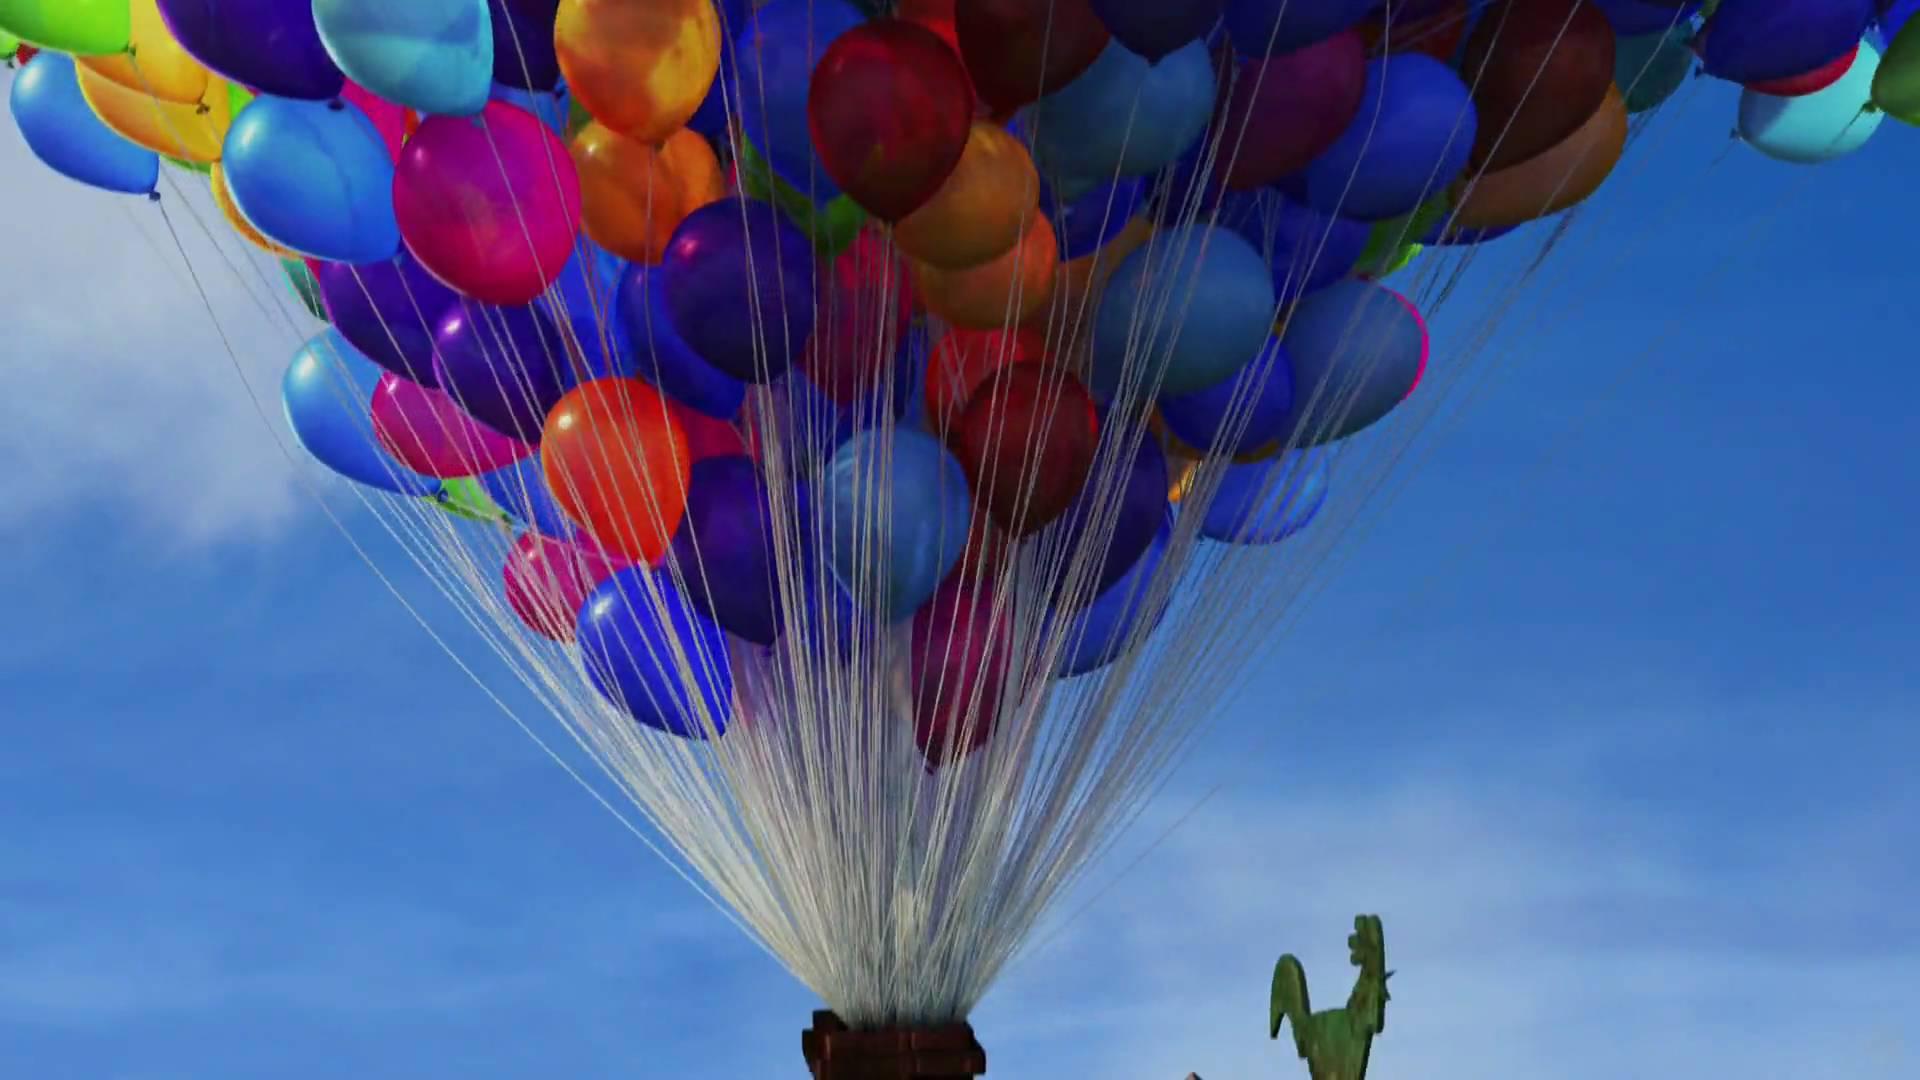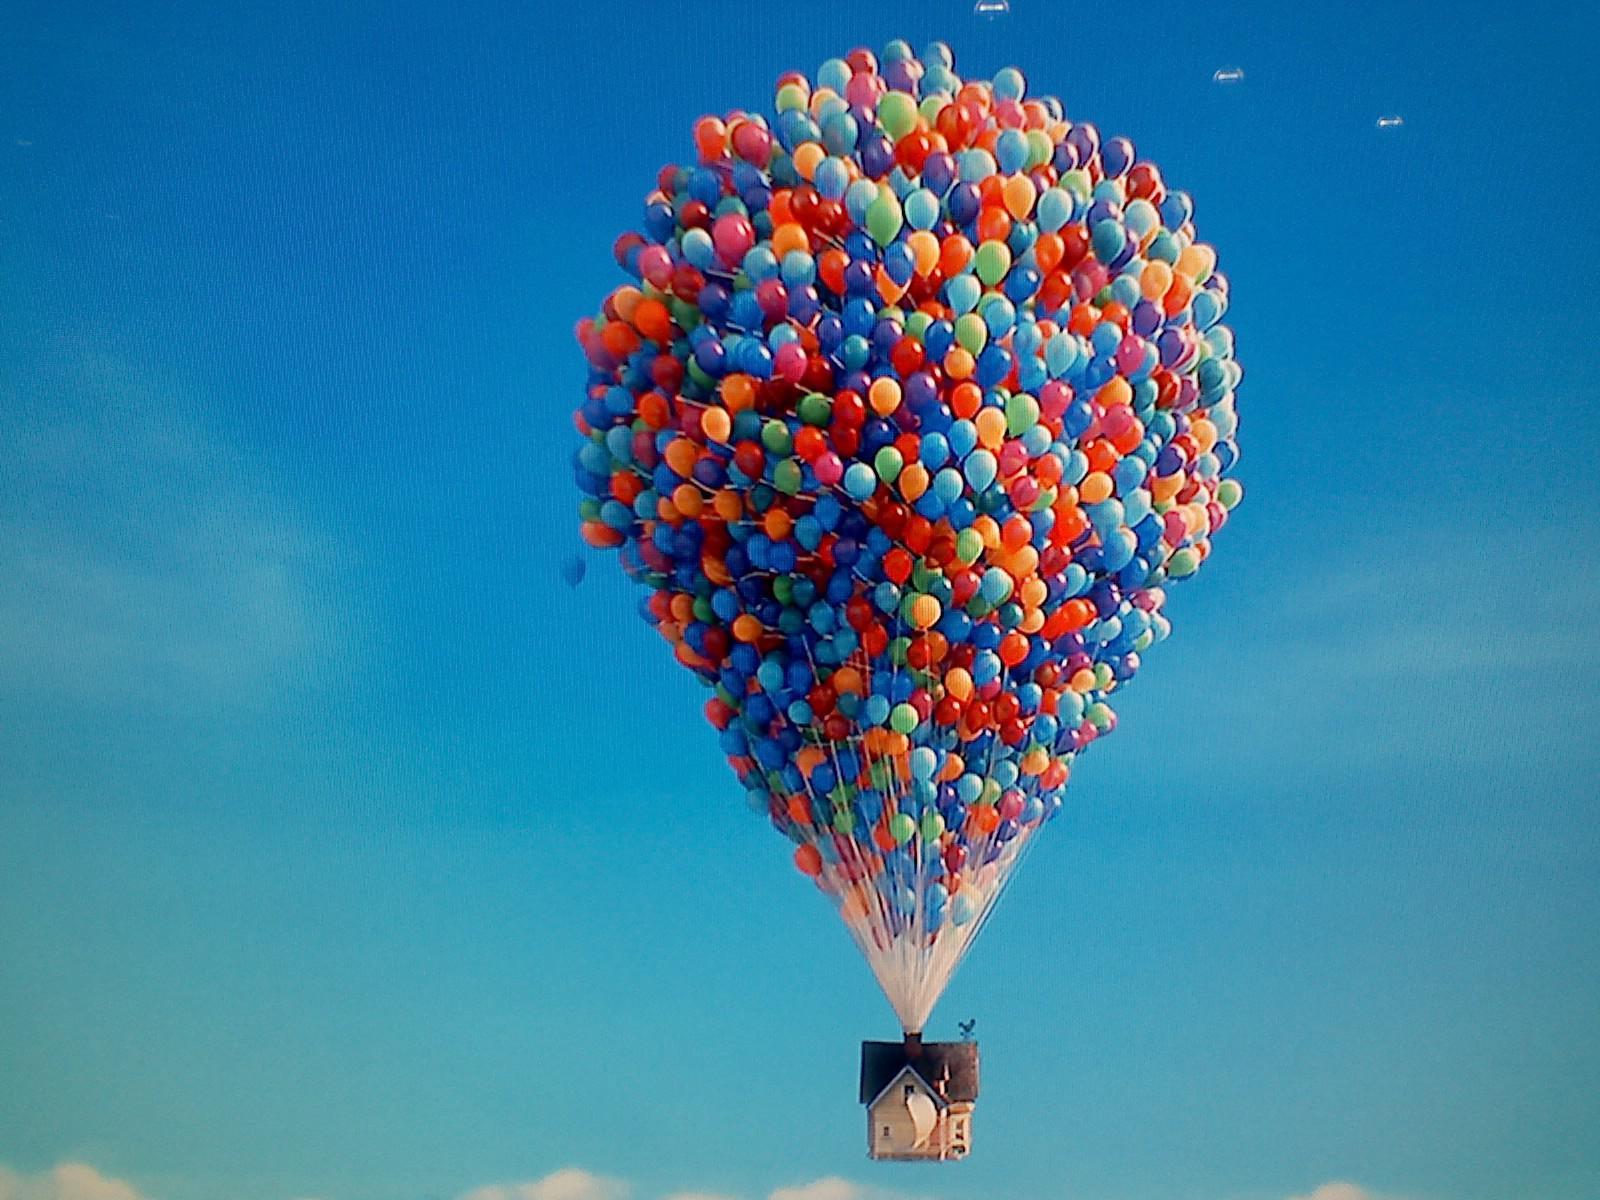The first image is the image on the left, the second image is the image on the right. Considering the images on both sides, is "Exactly one image shows a mass of balloons in the shape of a hot-air balloon, with their strings coming out of a chimney of a house, and the other image shows a bunch of balloons with no house attached under them." valid? Answer yes or no. No. 